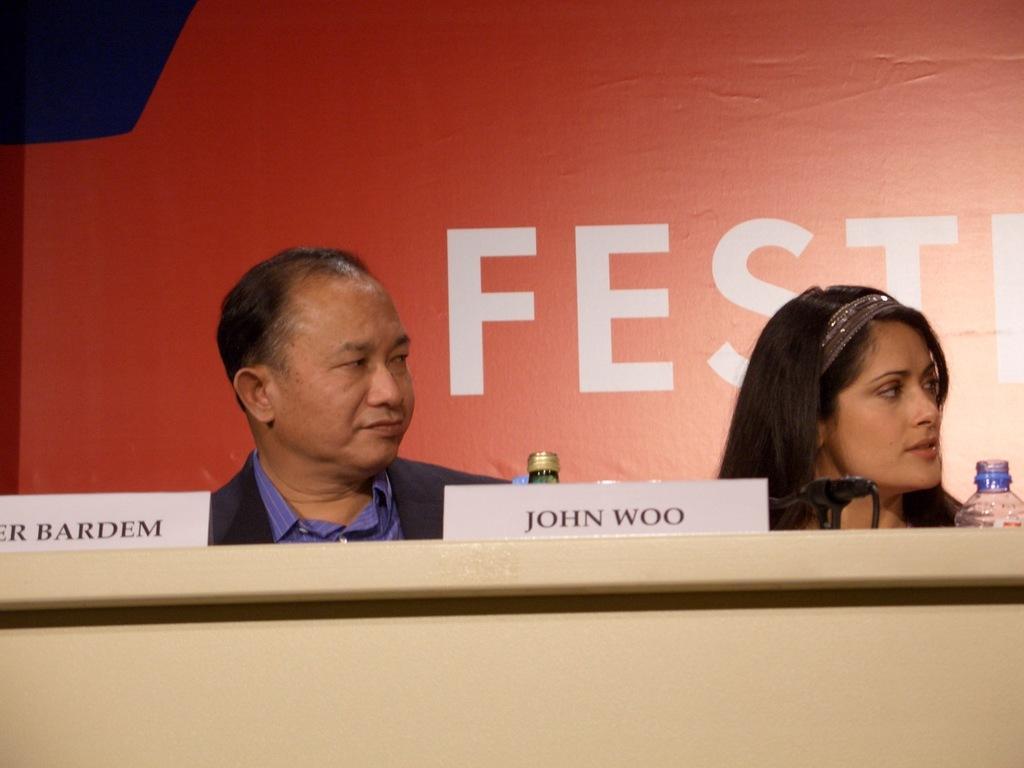In one or two sentences, can you explain what this image depicts? There is a man and woman. In front of them there is a table. On that there are name boards, bottles and mic. In the back there is a wall with something written. 